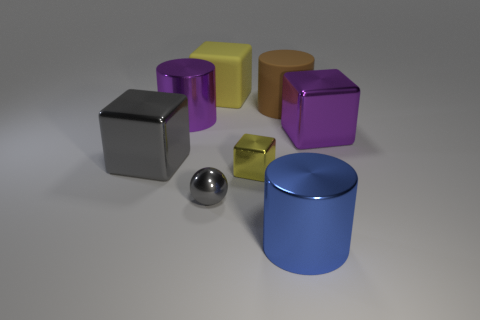How many other things are the same color as the small sphere?
Your response must be concise. 1. How many things are either gray objects behind the tiny ball or purple metallic cylinders?
Your response must be concise. 2. Do the brown cylinder and the yellow block that is behind the brown cylinder have the same size?
Your response must be concise. Yes. What is the size of the blue thing that is the same shape as the large brown thing?
Give a very brief answer. Large. There is a tiny object that is in front of the small metallic thing behind the small gray thing; how many gray metal things are behind it?
Your answer should be very brief. 1. What number of spheres are big brown objects or purple metal things?
Ensure brevity in your answer.  0. The cube to the right of the yellow cube that is right of the yellow thing that is behind the small yellow shiny block is what color?
Keep it short and to the point. Purple. How many other objects are the same size as the rubber cube?
Provide a short and direct response. 5. Is there any other thing that has the same shape as the yellow metal thing?
Provide a short and direct response. Yes. There is another big matte thing that is the same shape as the blue object; what is its color?
Your answer should be very brief. Brown. 